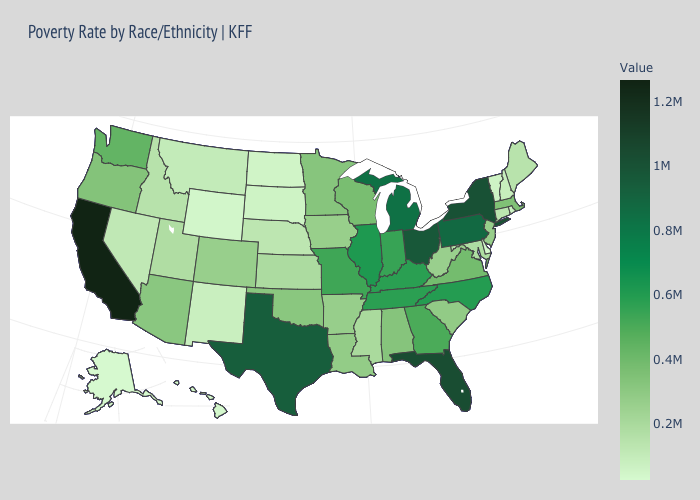Among the states that border Kansas , does Missouri have the highest value?
Answer briefly. Yes. Which states have the lowest value in the USA?
Answer briefly. Alaska. Does New York have the highest value in the Northeast?
Give a very brief answer. Yes. 